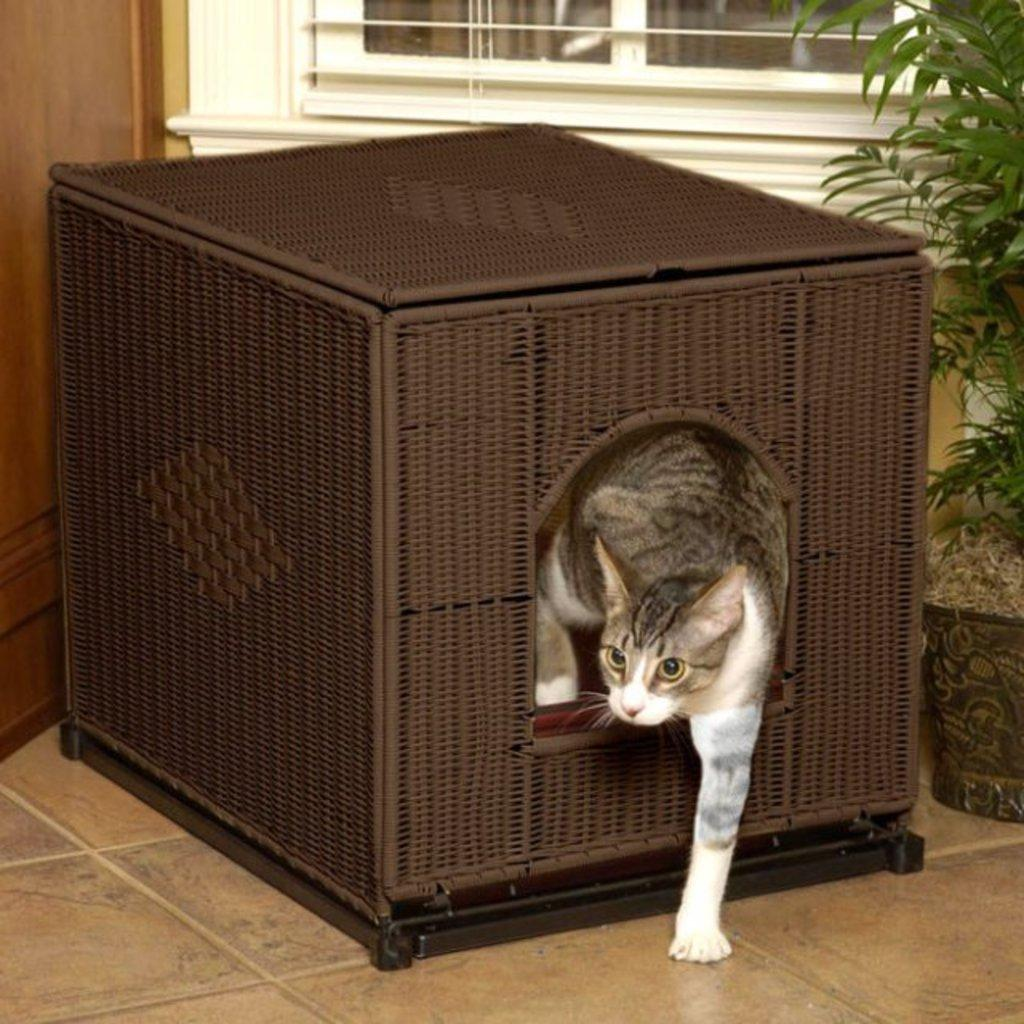What type of animal is in the image? There is a cat in the image. What is the cat doing in the image? The cat has one leg outside of a brown object. What can be seen in the right corner of the image? There is a plant in the right corner of the image. What is visible in the background of the image? There is a window in the background of the image. What type of structure can be seen in the image? There is no specific structure mentioned in the provided facts; the image only shows a cat, a brown object, a plant, and a window. What color is the truck in the image? There is no truck present in the image. 